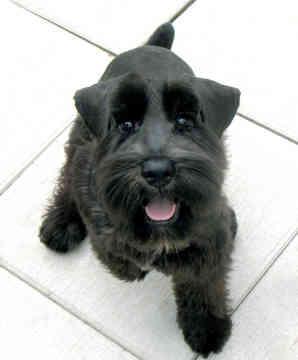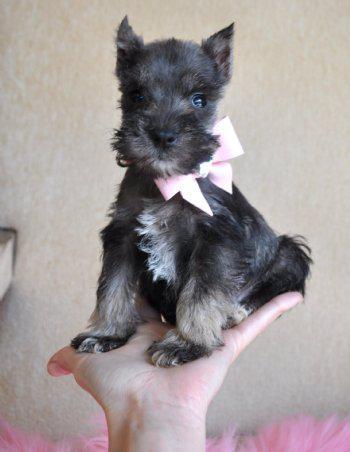The first image is the image on the left, the second image is the image on the right. For the images shown, is this caption "At least one dog has his head tilted to the right." true? Answer yes or no. No. The first image is the image on the left, the second image is the image on the right. For the images displayed, is the sentence "An image shows a puppy with paws on something with stringy yarn-like fibers." factually correct? Answer yes or no. No. 